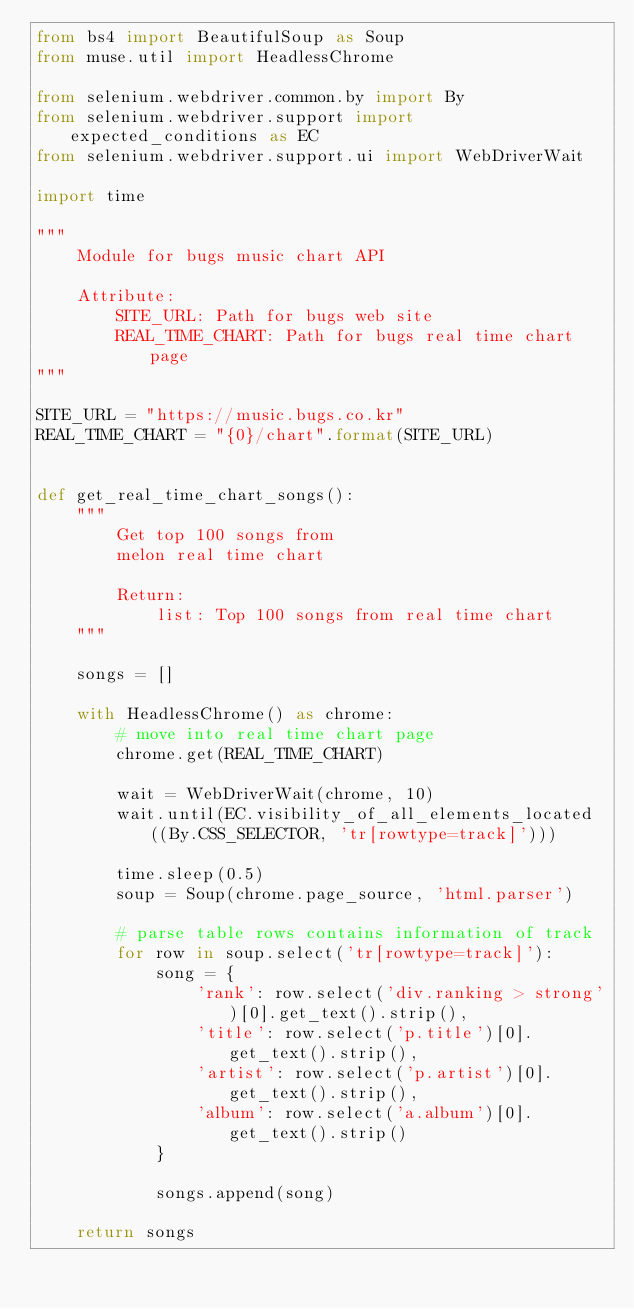Convert code to text. <code><loc_0><loc_0><loc_500><loc_500><_Python_>from bs4 import BeautifulSoup as Soup
from muse.util import HeadlessChrome

from selenium.webdriver.common.by import By
from selenium.webdriver.support import expected_conditions as EC
from selenium.webdriver.support.ui import WebDriverWait

import time

"""
    Module for bugs music chart API
    
    Attribute:
        SITE_URL: Path for bugs web site
        REAL_TIME_CHART: Path for bugs real time chart page
"""

SITE_URL = "https://music.bugs.co.kr"
REAL_TIME_CHART = "{0}/chart".format(SITE_URL)


def get_real_time_chart_songs():
    """
        Get top 100 songs from
        melon real time chart

        Return:
            list: Top 100 songs from real time chart
    """

    songs = []

    with HeadlessChrome() as chrome:
        # move into real time chart page
        chrome.get(REAL_TIME_CHART)

        wait = WebDriverWait(chrome, 10)
        wait.until(EC.visibility_of_all_elements_located((By.CSS_SELECTOR, 'tr[rowtype=track]')))

        time.sleep(0.5)
        soup = Soup(chrome.page_source, 'html.parser')

        # parse table rows contains information of track
        for row in soup.select('tr[rowtype=track]'):
            song = {
                'rank': row.select('div.ranking > strong')[0].get_text().strip(),
                'title': row.select('p.title')[0].get_text().strip(),
                'artist': row.select('p.artist')[0].get_text().strip(),
                'album': row.select('a.album')[0].get_text().strip()
            }

            songs.append(song)

    return songs
</code> 